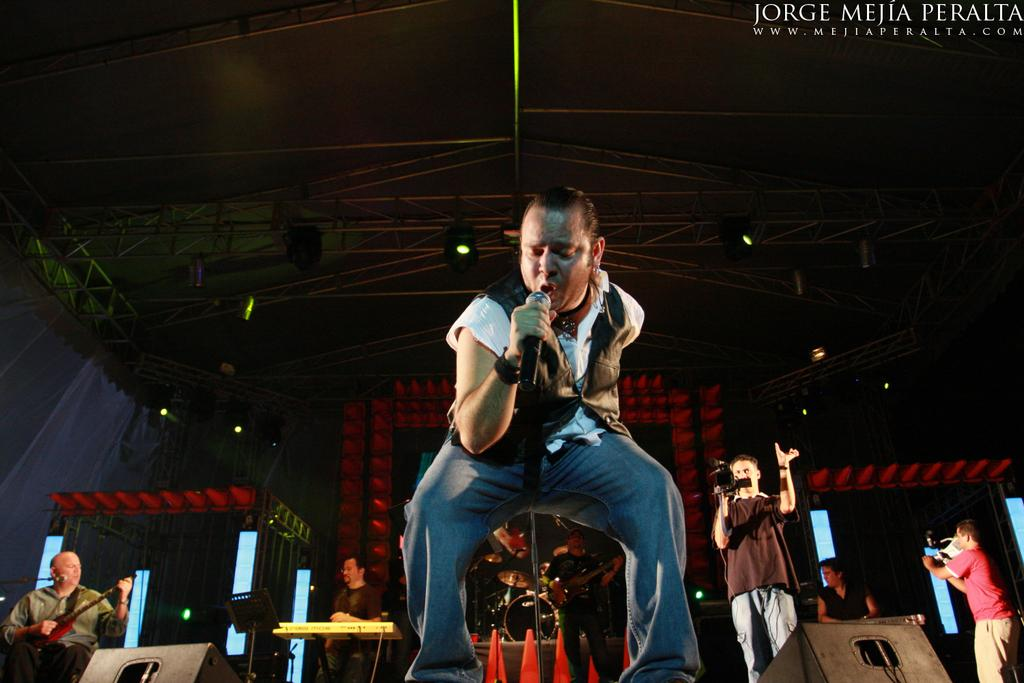What is the man on the stage doing? The man is standing on the stage and singing. What is the man holding while singing? The man is holding a microphone. Are there any other musicians on the stage? Yes, there are people playing musical instruments on the stage. What type of polish is the man applying to his shoes during the performance? There is no indication in the image that the man is applying any polish to his shoes while performing. 